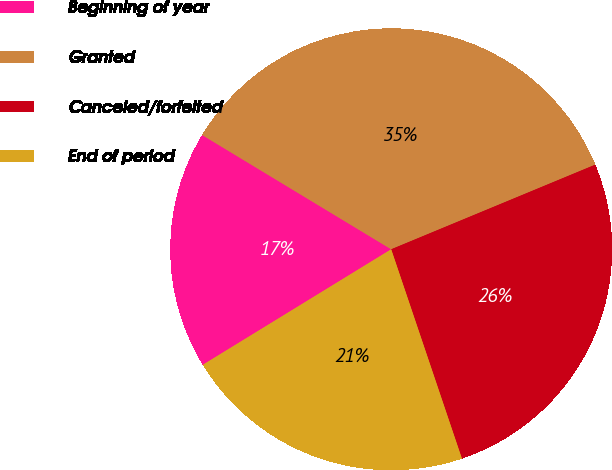Convert chart. <chart><loc_0><loc_0><loc_500><loc_500><pie_chart><fcel>Beginning of year<fcel>Granted<fcel>Canceled/forfeited<fcel>End of period<nl><fcel>17.41%<fcel>35.09%<fcel>26.07%<fcel>21.43%<nl></chart> 